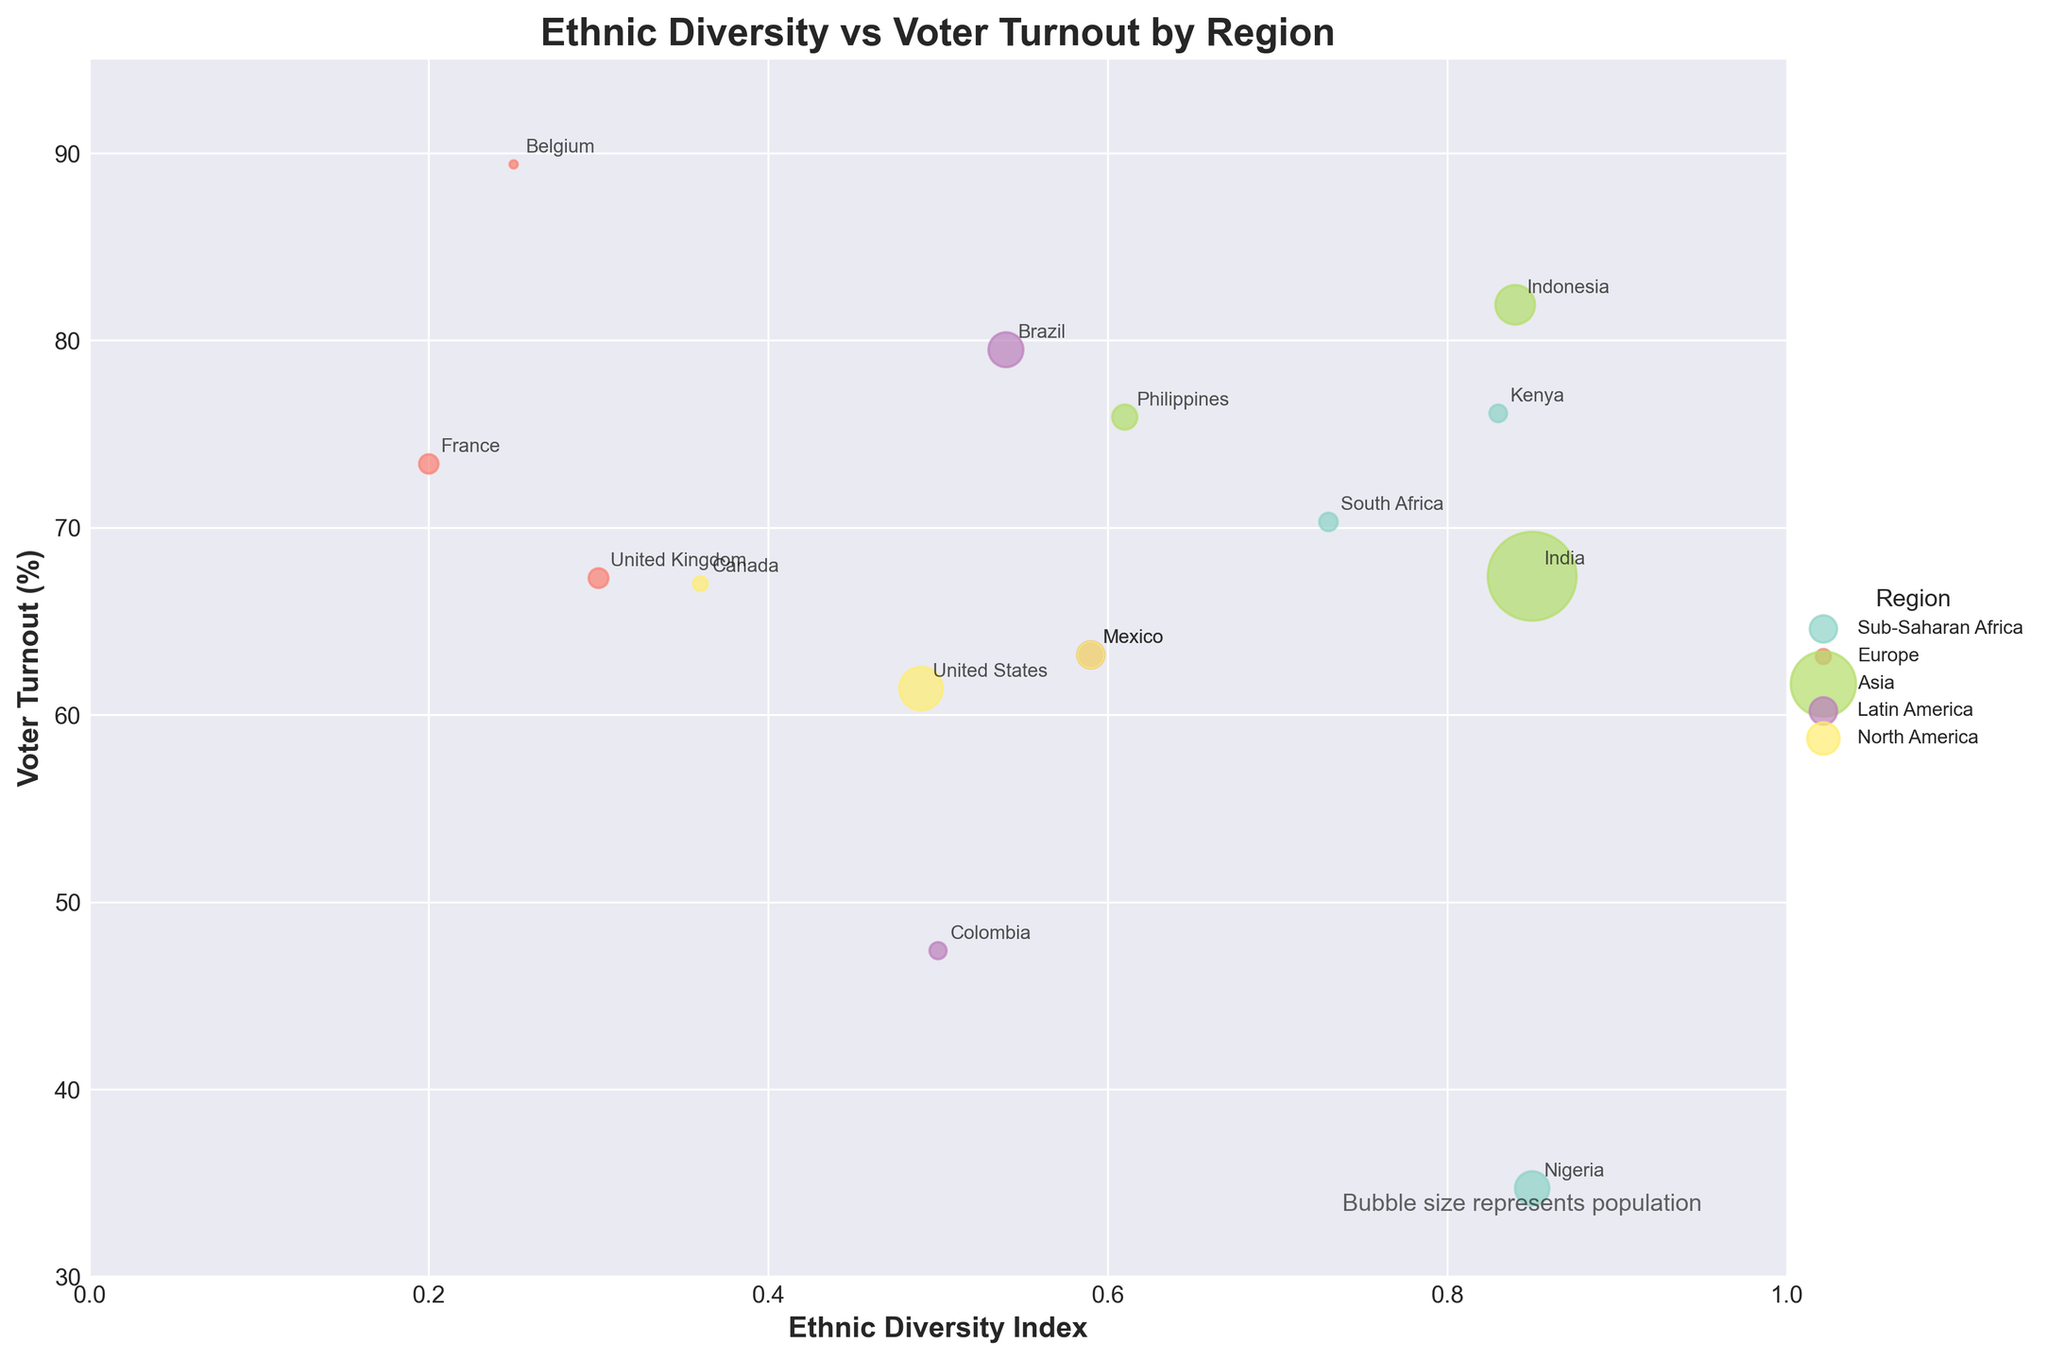How many countries are included in the Sub-Saharan Africa region? To find the number of countries in the Sub-Saharan Africa region, we look for all bubbles associated with this region and count them. There are three bubbles labeled South Africa, Nigeria, and Kenya.
Answer: 3 What is the range of voter turnout in the Asia region? To determine the range, we find the minimum and maximum voter turnout percentages for the countries in the Asia region. The countries are India (67.4%), Indonesia (81.9%), and Philippines (75.9%). The range is the difference between the highest and lowest values. So, the range is 81.9-67.4 = 14.5%.
Answer: 14.5 Which country has the highest ethnic diversity index and what is its percentage of voter turnout? We find the country with the highest ethnic diversity index by looking at the figure. Nigeria has the highest index of 0.85. The corresponding voter turnout for Nigeria is 34.7%.
Answer: Nigeria, 34.7% Compare voter turnout between European countries and North American countries. Which region has a generally higher turnout rate? To compare, we observe the voter turnout percentages for European countries (France: 73.4%, UK: 67.3%, Belgium: 89.4%) and North American countries (US: 61.4%, Canada: 67.0%, Mexico: 63.2%). Most European countries have percentages above 67%, while North American countries mostly fall below 67%. Therefore, Europe seems to have a generally higher turnout rate.
Answer: Europe What can be inferred about the relationship between ethnic diversity index and voter turnout for countries in the Latin America region? In the Latin America region, we examine the countries and their respective indices and turnout: Brazil (0.54, 79.5%), Mexico (0.59, 63.2%), Colombia (0.50, 47.4%). Brazil and Mexico have moderate diversity indices but the voter turnout varies significantly, from high to middle. Colombia has a lower voter turnout with a moderate diversity index. No strong correlation can be inferred directly from these observations; each case varies.
Answer: No strong correlation Which country has the largest population, and in which region is it located? To determine this, we look at the sizes of the bubbles, with larger bubbles indicating larger populations. India has the largest bubble, indicating it has the largest population (1,380,004,385 people). It is located in the Asia region.
Answer: India, Asia Is there any region where all the countries have voter turnouts below 70%? We check each region to see if all its countries have voter turnouts below 70%. In North America, the US (61.4%) and Canada (67.0%) are both below 70%, and Mexico is exactly 63.2%. So, all countries in North America have turnouts below 70%.
Answer: North America How does voter turnout vary within the Sub-Saharan Africa region? In the Sub-Saharan Africa region, we have South Africa (70.3%), Nigeria (34.7%), and Kenya (76.1%). This shows a wide variation in voter turnout, from as low as 34.7% in Nigeria to as high as 76.1% in Kenya.
Answer: Wide variation Which country in the Europe region has the lowest ethnic diversity index and what is their voter turnout? To find this, we compare the ethnic diversity indices of the European countries: France (0.20), UK (0.30), Belgium (0.25). France (0.20) has the lowest ethnic diversity index. The voter turnout in France is 73.4%.
Answer: France, 73.4% What is the average ethnic diversity index for countries in the Asia region? We calculate the average by summing the ethnic diversity indices of the Asian countries (0.85 for India, 0.84 for Indonesia, and 0.61 for Philippines) and dividing by the number of countries. Thus, (0.85 + 0.84 + 0.61) / 3 = 2.30 / 3 = 0.767.
Answer: 0.767 